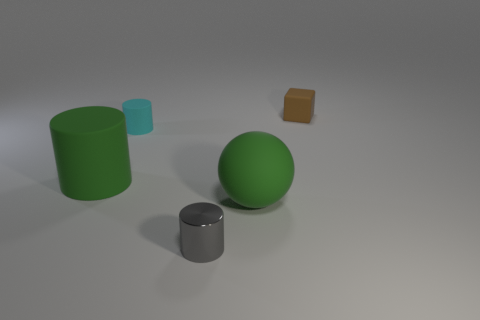Is the number of cyan rubber things left of the brown matte object greater than the number of tiny cyan matte cylinders in front of the green cylinder?
Ensure brevity in your answer.  Yes. Does the large matte object on the right side of the big cylinder have the same color as the large object left of the gray metal cylinder?
Your answer should be very brief. Yes. There is a green thing to the right of the tiny matte object that is in front of the small rubber object behind the cyan cylinder; what size is it?
Provide a short and direct response. Large. The big object that is the same shape as the small gray thing is what color?
Provide a succinct answer. Green. Are there more brown cubes that are left of the tiny rubber cylinder than cylinders?
Offer a terse response. No. There is a tiny cyan rubber thing; is its shape the same as the big rubber thing that is to the left of the ball?
Offer a very short reply. Yes. The green thing that is the same shape as the small cyan thing is what size?
Provide a short and direct response. Large. Is the number of green matte spheres greater than the number of small blue metallic cylinders?
Provide a short and direct response. Yes. Do the small metal object and the cyan rubber thing have the same shape?
Give a very brief answer. Yes. What is the tiny cylinder right of the small matte thing on the left side of the tiny brown rubber cube made of?
Keep it short and to the point. Metal. 